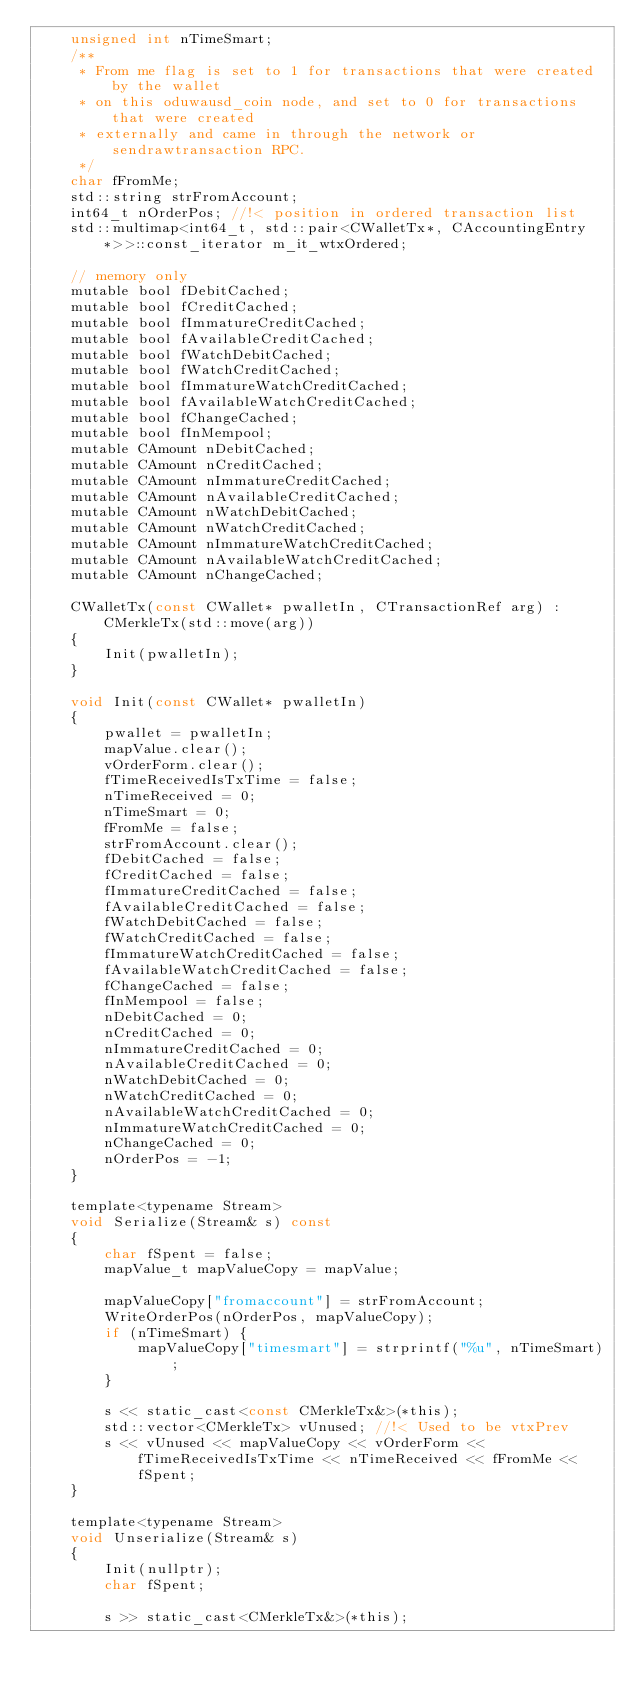<code> <loc_0><loc_0><loc_500><loc_500><_C_>    unsigned int nTimeSmart;
    /**
     * From me flag is set to 1 for transactions that were created by the wallet
     * on this oduwausd_coin node, and set to 0 for transactions that were created
     * externally and came in through the network or sendrawtransaction RPC.
     */
    char fFromMe;
    std::string strFromAccount;
    int64_t nOrderPos; //!< position in ordered transaction list
    std::multimap<int64_t, std::pair<CWalletTx*, CAccountingEntry*>>::const_iterator m_it_wtxOrdered;

    // memory only
    mutable bool fDebitCached;
    mutable bool fCreditCached;
    mutable bool fImmatureCreditCached;
    mutable bool fAvailableCreditCached;
    mutable bool fWatchDebitCached;
    mutable bool fWatchCreditCached;
    mutable bool fImmatureWatchCreditCached;
    mutable bool fAvailableWatchCreditCached;
    mutable bool fChangeCached;
    mutable bool fInMempool;
    mutable CAmount nDebitCached;
    mutable CAmount nCreditCached;
    mutable CAmount nImmatureCreditCached;
    mutable CAmount nAvailableCreditCached;
    mutable CAmount nWatchDebitCached;
    mutable CAmount nWatchCreditCached;
    mutable CAmount nImmatureWatchCreditCached;
    mutable CAmount nAvailableWatchCreditCached;
    mutable CAmount nChangeCached;

    CWalletTx(const CWallet* pwalletIn, CTransactionRef arg) : CMerkleTx(std::move(arg))
    {
        Init(pwalletIn);
    }

    void Init(const CWallet* pwalletIn)
    {
        pwallet = pwalletIn;
        mapValue.clear();
        vOrderForm.clear();
        fTimeReceivedIsTxTime = false;
        nTimeReceived = 0;
        nTimeSmart = 0;
        fFromMe = false;
        strFromAccount.clear();
        fDebitCached = false;
        fCreditCached = false;
        fImmatureCreditCached = false;
        fAvailableCreditCached = false;
        fWatchDebitCached = false;
        fWatchCreditCached = false;
        fImmatureWatchCreditCached = false;
        fAvailableWatchCreditCached = false;
        fChangeCached = false;
        fInMempool = false;
        nDebitCached = 0;
        nCreditCached = 0;
        nImmatureCreditCached = 0;
        nAvailableCreditCached = 0;
        nWatchDebitCached = 0;
        nWatchCreditCached = 0;
        nAvailableWatchCreditCached = 0;
        nImmatureWatchCreditCached = 0;
        nChangeCached = 0;
        nOrderPos = -1;
    }

    template<typename Stream>
    void Serialize(Stream& s) const
    {
        char fSpent = false;
        mapValue_t mapValueCopy = mapValue;

        mapValueCopy["fromaccount"] = strFromAccount;
        WriteOrderPos(nOrderPos, mapValueCopy);
        if (nTimeSmart) {
            mapValueCopy["timesmart"] = strprintf("%u", nTimeSmart);
        }

        s << static_cast<const CMerkleTx&>(*this);
        std::vector<CMerkleTx> vUnused; //!< Used to be vtxPrev
        s << vUnused << mapValueCopy << vOrderForm << fTimeReceivedIsTxTime << nTimeReceived << fFromMe << fSpent;
    }

    template<typename Stream>
    void Unserialize(Stream& s)
    {
        Init(nullptr);
        char fSpent;

        s >> static_cast<CMerkleTx&>(*this);</code> 